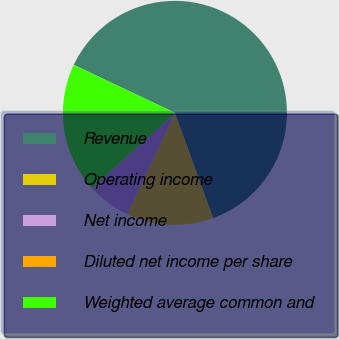Convert chart to OTSL. <chart><loc_0><loc_0><loc_500><loc_500><pie_chart><fcel>Revenue<fcel>Operating income<fcel>Net income<fcel>Diluted net income per share<fcel>Weighted average common and<nl><fcel>62.41%<fcel>12.52%<fcel>6.28%<fcel>0.04%<fcel>18.75%<nl></chart> 